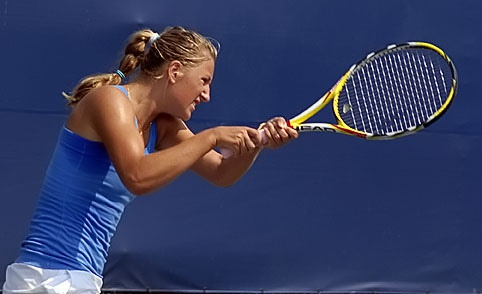Describe the objects in this image and their specific colors. I can see people in navy, maroon, salmon, and blue tones and tennis racket in navy, black, gray, and lightgray tones in this image. 